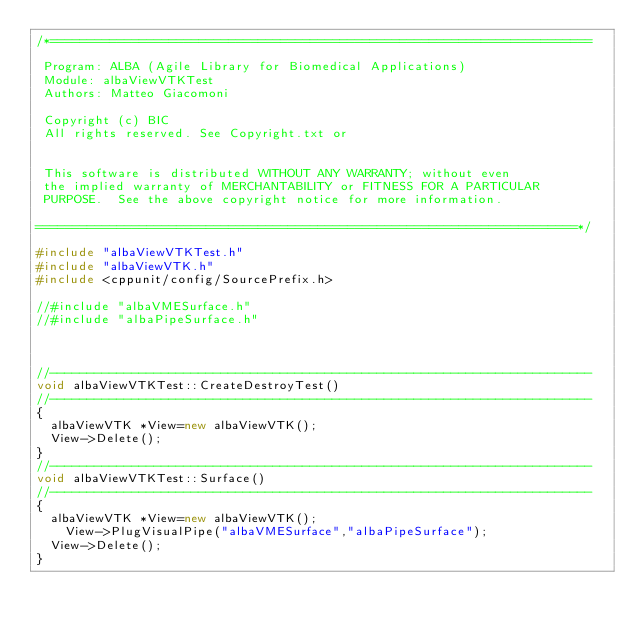<code> <loc_0><loc_0><loc_500><loc_500><_C++_>/*=========================================================================

 Program: ALBA (Agile Library for Biomedical Applications)
 Module: albaViewVTKTest
 Authors: Matteo Giacomoni
 
 Copyright (c) BIC
 All rights reserved. See Copyright.txt or


 This software is distributed WITHOUT ANY WARRANTY; without even
 the implied warranty of MERCHANTABILITY or FITNESS FOR A PARTICULAR
 PURPOSE.  See the above copyright notice for more information.

=========================================================================*/

#include "albaViewVTKTest.h"
#include "albaViewVTK.h"
#include <cppunit/config/SourcePrefix.h>

//#include "albaVMESurface.h"
//#include "albaPipeSurface.h"



//-------------------------------------------------------------------------
void albaViewVTKTest::CreateDestroyTest()
//-------------------------------------------------------------------------
{
  albaViewVTK *View=new albaViewVTK();
  View->Delete();
}
//-------------------------------------------------------------------------
void albaViewVTKTest::Surface()
//-------------------------------------------------------------------------
{
  albaViewVTK *View=new albaViewVTK();
	View->PlugVisualPipe("albaVMESurface","albaPipeSurface");
  View->Delete();
}
</code> 